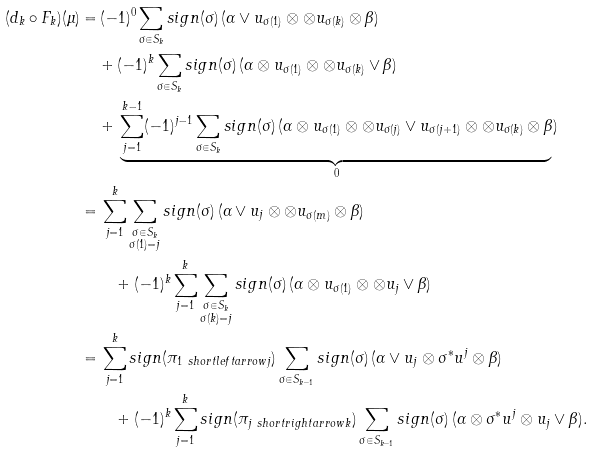<formula> <loc_0><loc_0><loc_500><loc_500>( d _ { k } \circ F _ { k } ) ( \mu ) = & \, ( - 1 ) ^ { 0 } \sum _ { \sigma \in S _ { k } } s i g n ( \sigma ) \, ( \alpha \vee u _ { \sigma ( 1 ) } \otimes \otimes u _ { \sigma ( k ) } \otimes \beta ) \\ & + ( - 1 ) ^ { k } \sum _ { \sigma \in S _ { k } } s i g n ( \sigma ) \, ( \alpha \otimes u _ { \sigma ( 1 ) } \otimes \otimes u _ { \sigma ( k ) } \vee \beta ) \\ & + \, \underbrace { \sum _ { j = 1 } ^ { k - 1 } ( - 1 ) ^ { j - 1 } \sum _ { \sigma \in S _ { k } } s i g n ( \sigma ) \, ( \alpha \otimes u _ { \sigma ( 1 ) } \otimes \otimes u _ { \sigma ( j ) } \vee u _ { \sigma ( j + 1 ) } \otimes \otimes u _ { \sigma ( k ) } \otimes \beta } _ { 0 } ) \\ = & \, \sum _ { j = 1 } ^ { k } \sum _ { \substack { \sigma \in S _ { k } \\ \sigma ( 1 ) = j } } s i g n ( \sigma ) \, ( \alpha \vee u _ { j } \otimes \otimes u _ { \sigma ( m ) } \otimes \beta ) \\ & \quad + ( - 1 ) ^ { k } \sum _ { j = 1 } ^ { k } \sum _ { \substack { \sigma \in S _ { k } \\ \sigma ( k ) = j } } s i g n ( \sigma ) \, ( \alpha \otimes u _ { \sigma ( 1 ) } \otimes \otimes u _ { j } \vee \beta ) \\ = & \, \sum _ { j = 1 } ^ { k } s i g n ( \pi _ { 1 \ s h o r t l e f t a r r o w j } ) \sum _ { \sigma \in S _ { k - 1 } } s i g n ( \sigma ) \, ( \alpha \vee u _ { j } \otimes \sigma ^ { * } u ^ { j } \otimes \beta ) \\ & \quad + ( - 1 ) ^ { k } \sum _ { j = 1 } ^ { k } s i g n ( \pi _ { j \ s h o r t r i g h t a r r o w k } ) \sum _ { \sigma \in S _ { k - 1 } } s i g n ( \sigma ) \, ( \alpha \otimes \sigma ^ { * } u ^ { j } \otimes u _ { j } \vee \beta ) .</formula> 